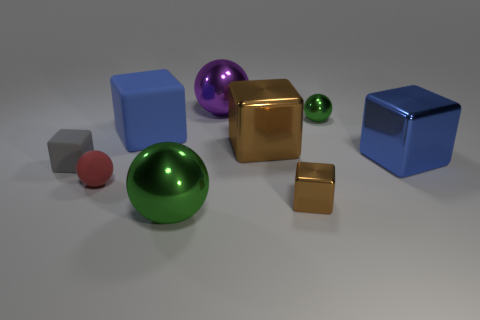Subtract all tiny rubber blocks. How many blocks are left? 4 Subtract all gray cubes. How many cubes are left? 4 Subtract 1 spheres. How many spheres are left? 3 Subtract all brown spheres. Subtract all purple cylinders. How many spheres are left? 4 Add 1 tiny brown shiny objects. How many objects exist? 10 Subtract all spheres. How many objects are left? 5 Subtract all brown blocks. Subtract all matte spheres. How many objects are left? 6 Add 9 large blue shiny cubes. How many large blue shiny cubes are left? 10 Add 8 tiny gray rubber objects. How many tiny gray rubber objects exist? 9 Subtract 1 red balls. How many objects are left? 8 